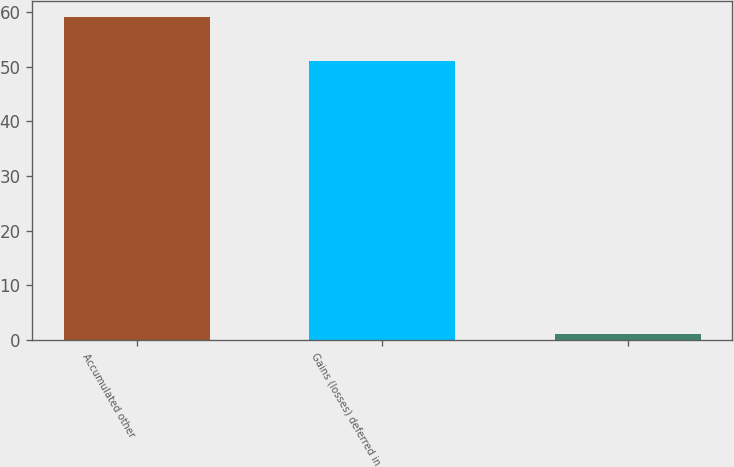Convert chart. <chart><loc_0><loc_0><loc_500><loc_500><bar_chart><fcel>Accumulated other<fcel>Gains (losses) deferred in<fcel>Unnamed: 2<nl><fcel>59<fcel>51<fcel>1<nl></chart> 